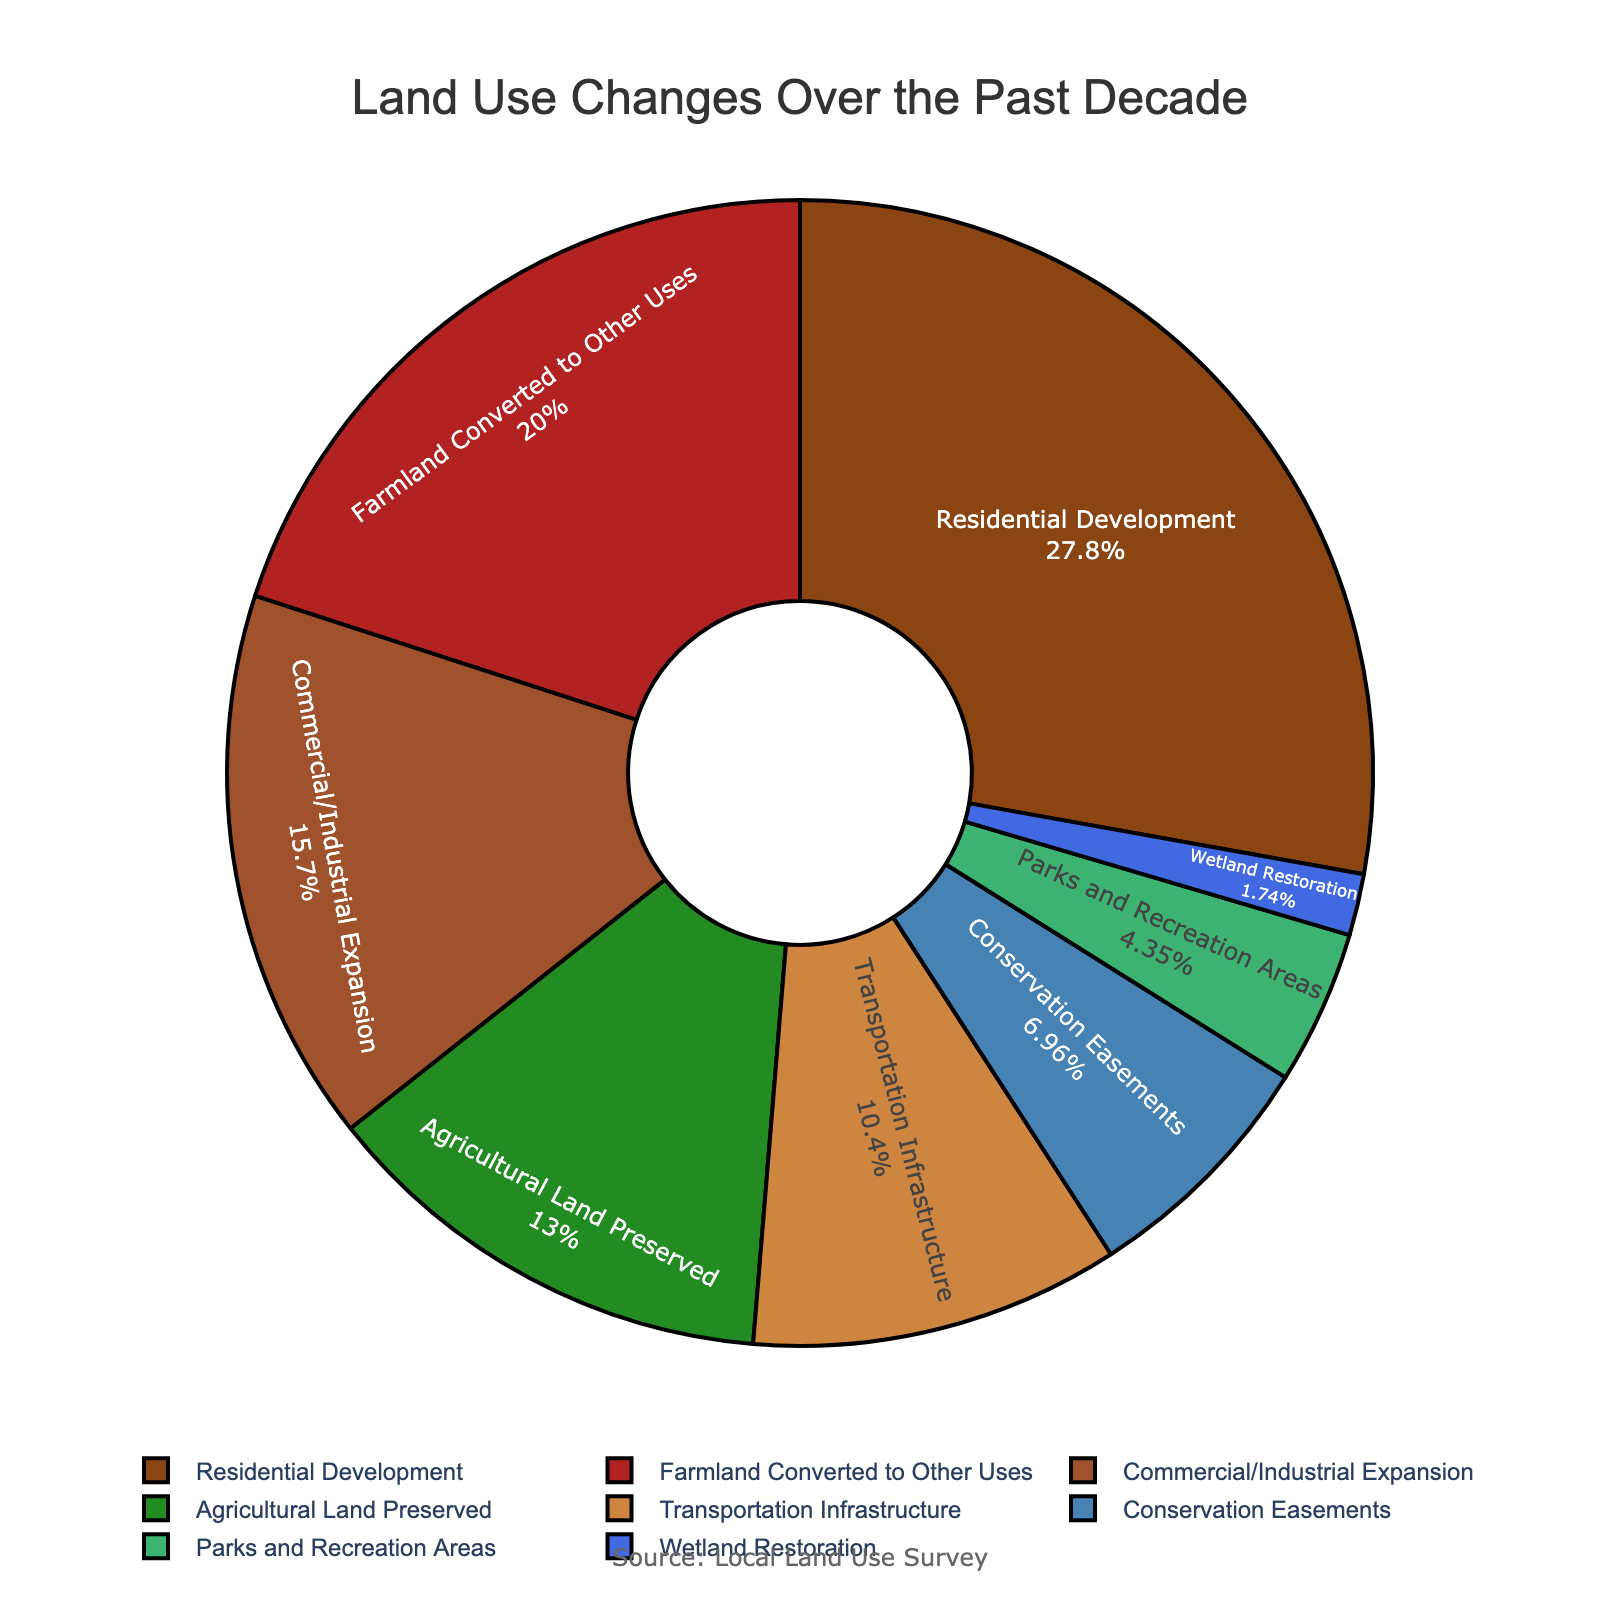What percentage of land use change is attributed to Residential Development? The pie chart indicates the percentage values for each type of land use change. Locate the section labeled "Residential Development" and read the corresponding percentage.
Answer: 32% Which land use type experienced the least change? To determine the least percentage of change, review the pie chart for the smallest segment or the one labeled with the smallest percentage.
Answer: Wetland Restoration How much more land was converted to Farmland Converted to Other Uses compared to Parks and Recreation Areas? Identify the percentages for both Farmland Converted to Other Uses and Parks and Recreation Areas in the chart. Subtract the latter's percentage from the former's.
Answer: 23% - 5% = 18% What is the total percentage of land use change attributed to Conservation Efforts (Conservation Easements and Wetland Restoration combined)? Find the segments representing Conservation Easements and Wetland Restoration. Sum their percentages: 8% and 2%.
Answer: 8% + 2% = 10% Which category had the largest increase in land use, Residential Development or Commercial/Industrial Expansion? Compare the percentage values for both Residential Development and Commercial/Industrial Expansion provided in the chart.
Answer: Residential Development What color represents Agricultural Land Preserved in the pie chart? Look for the corresponding section labeled "Agricultural Land Preserved" within the chart and note its color.
Answer: Green What is the total percentage change for all non-agricultural land use types combined? Add the percentages of all categories excluding Agricultural Land Preserved (15%): Residential Development (32%), Commercial/Industrial Expansion (18%), Transportation Infrastructure (12%), Farmland Converted to Other Uses (23%), Parks and Recreation Areas (5%), Conservation Easements (8%), Wetland Restoration (2%).
Answer: 32% + 18% + 12% + 23% + 5% + 8% + 2% = 100% Does Farmland Converted to Other Uses exceed the combined percentage of Parks and Recreation Areas, Conservation Easements, and Wetland Restoration? Sum the percentages of Parks and Recreation Areas (5%), Conservation Easements (8%), and Wetland Restoration (2%): 5% + 8% + 2% = 15%. Compare this with Farmland Converted to Other Uses (23%).
Answer: Yes What is the difference in percentage points between Transportation Infrastructure and Agricultural Land Preserved? Locate the percentages for Transportation Infrastructure (12%) and Agricultural Land Preserved (15%) on the chart. Subtract the smaller value from the larger one.
Answer: 15% - 12% = 3% Which change category occupies the darkest segment in the pie chart? Identify the segment with the darkest color on the chart linked to a land use type.
Answer: Residential Development 